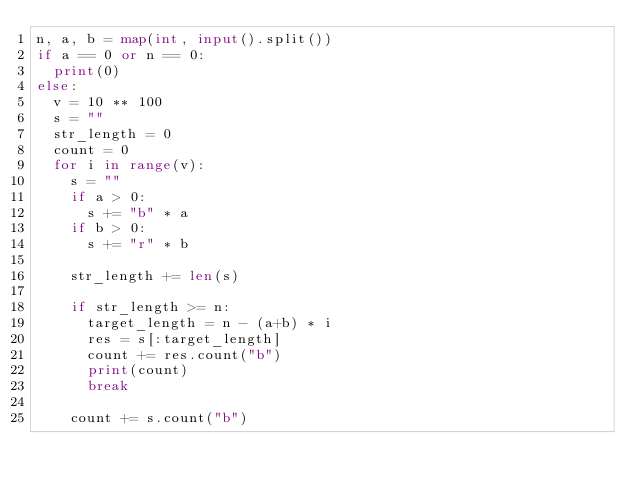<code> <loc_0><loc_0><loc_500><loc_500><_Python_>n, a, b = map(int, input().split())
if a == 0 or n == 0:
  print(0)
else:
  v = 10 ** 100
  s = ""
  str_length = 0
  count = 0
  for i in range(v):
    s = ""
    if a > 0:
      s += "b" * a
    if b > 0:
      s += "r" * b
    
    str_length += len(s)
    
    if str_length >= n:
      target_length = n - (a+b) * i
      res = s[:target_length]
      count += res.count("b")
      print(count)
      break

    count += s.count("b")    

  </code> 